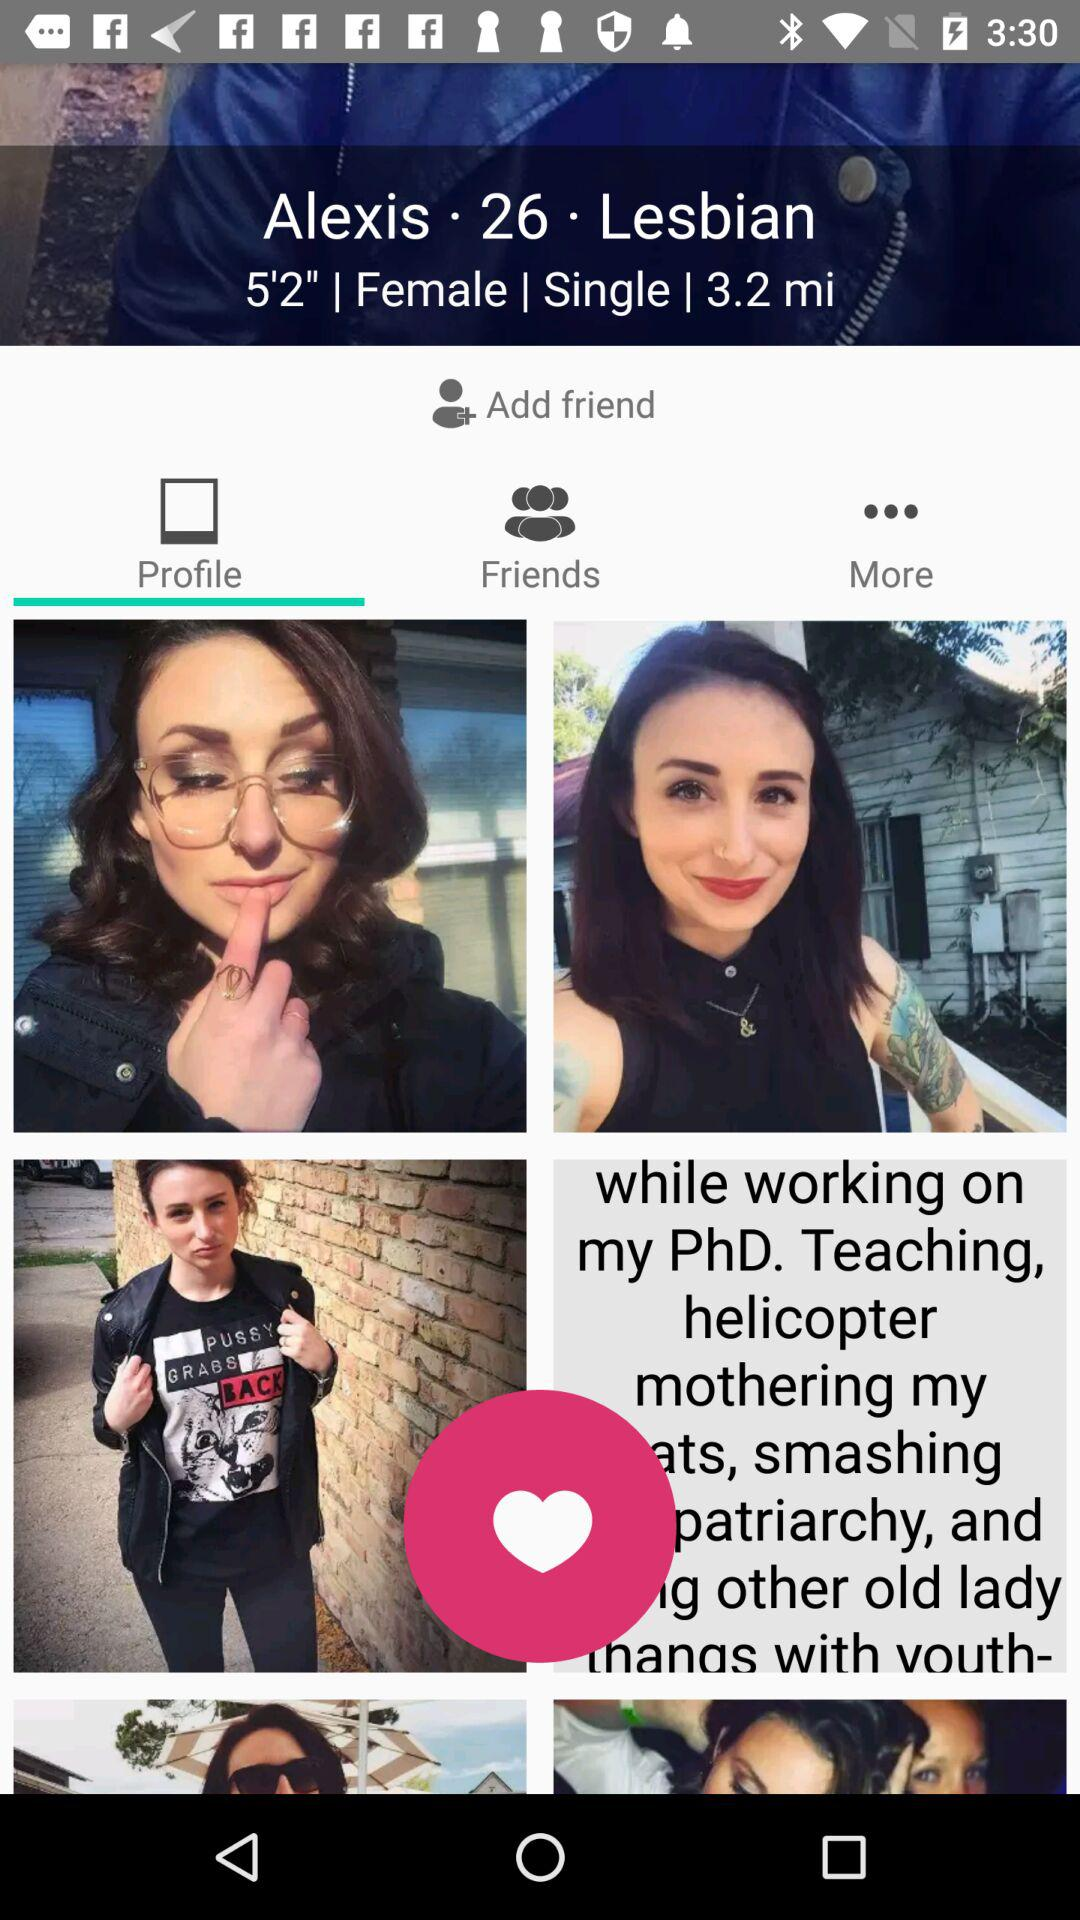What is the height of Alexis? The height of Alexis is 5'2". 